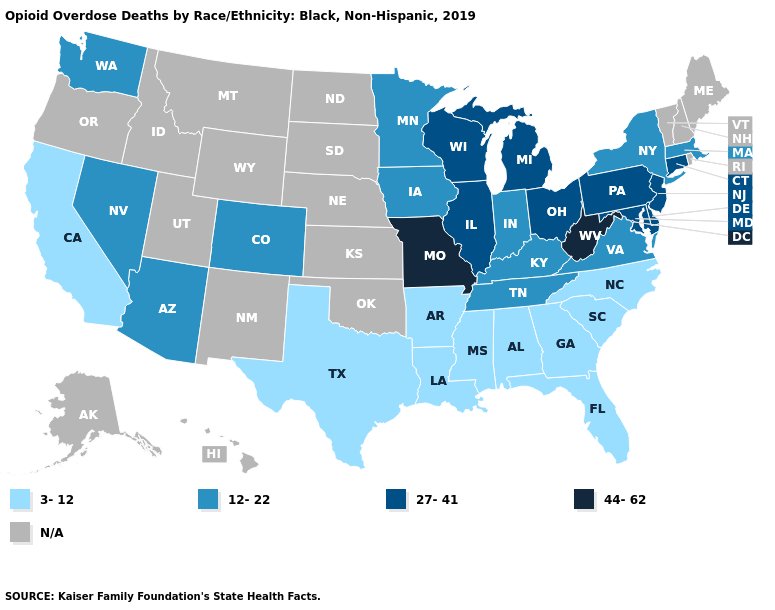Name the states that have a value in the range N/A?
Be succinct. Alaska, Hawaii, Idaho, Kansas, Maine, Montana, Nebraska, New Hampshire, New Mexico, North Dakota, Oklahoma, Oregon, Rhode Island, South Dakota, Utah, Vermont, Wyoming. Among the states that border Georgia , which have the highest value?
Be succinct. Tennessee. Which states have the lowest value in the USA?
Answer briefly. Alabama, Arkansas, California, Florida, Georgia, Louisiana, Mississippi, North Carolina, South Carolina, Texas. Name the states that have a value in the range 44-62?
Keep it brief. Missouri, West Virginia. Name the states that have a value in the range 27-41?
Write a very short answer. Connecticut, Delaware, Illinois, Maryland, Michigan, New Jersey, Ohio, Pennsylvania, Wisconsin. What is the value of Pennsylvania?
Concise answer only. 27-41. Does Missouri have the highest value in the USA?
Short answer required. Yes. Is the legend a continuous bar?
Concise answer only. No. Name the states that have a value in the range 44-62?
Concise answer only. Missouri, West Virginia. Does Connecticut have the highest value in the Northeast?
Be succinct. Yes. What is the value of Pennsylvania?
Write a very short answer. 27-41. Name the states that have a value in the range 44-62?
Give a very brief answer. Missouri, West Virginia. What is the value of Kentucky?
Concise answer only. 12-22. Which states have the lowest value in the USA?
Be succinct. Alabama, Arkansas, California, Florida, Georgia, Louisiana, Mississippi, North Carolina, South Carolina, Texas. 